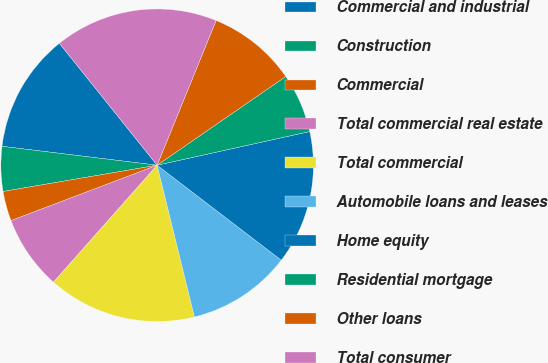<chart> <loc_0><loc_0><loc_500><loc_500><pie_chart><fcel>Commercial and industrial<fcel>Construction<fcel>Commercial<fcel>Total commercial real estate<fcel>Total commercial<fcel>Automobile loans and leases<fcel>Home equity<fcel>Residential mortgage<fcel>Other loans<fcel>Total consumer<nl><fcel>12.31%<fcel>4.62%<fcel>3.08%<fcel>7.69%<fcel>15.38%<fcel>10.77%<fcel>13.85%<fcel>6.15%<fcel>9.23%<fcel>16.92%<nl></chart> 